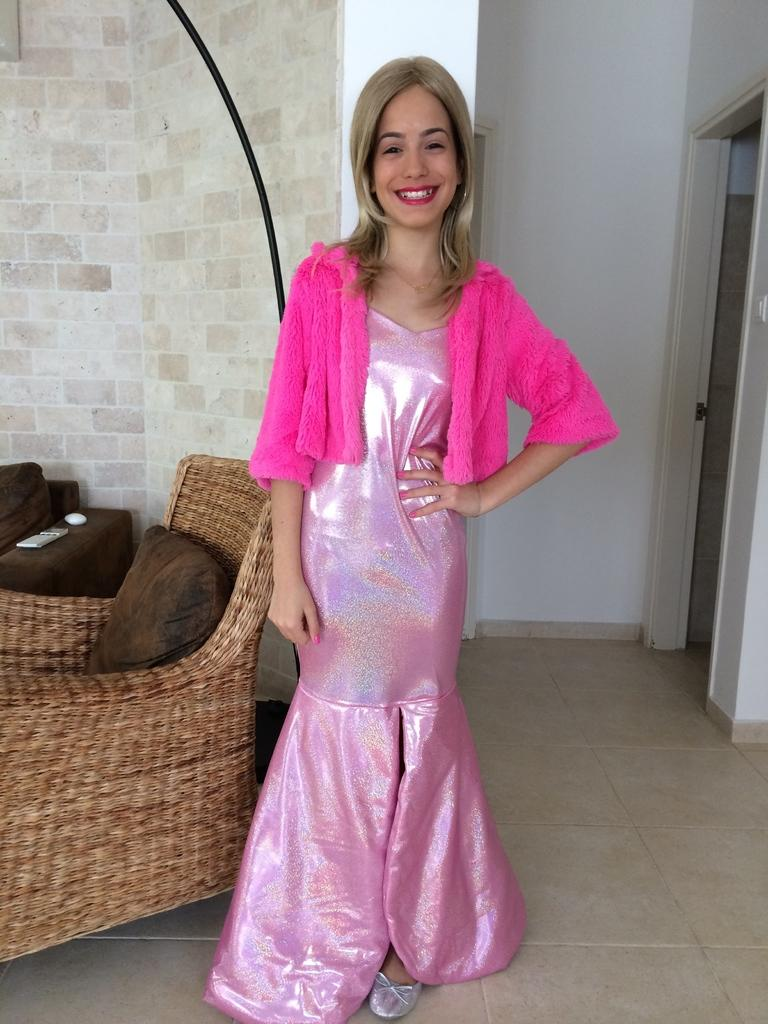What is the person in the image wearing? The person is wearing a pink dress in the image. What type of furniture is to the left of the person? There are couches and pillows to the left of the person. What can be seen in the background of the image? There is a wall visible in the background of the image. What type of badge is the person wearing on their slip in the image? There is no badge or slip present in the image; the person is wearing a pink dress. 